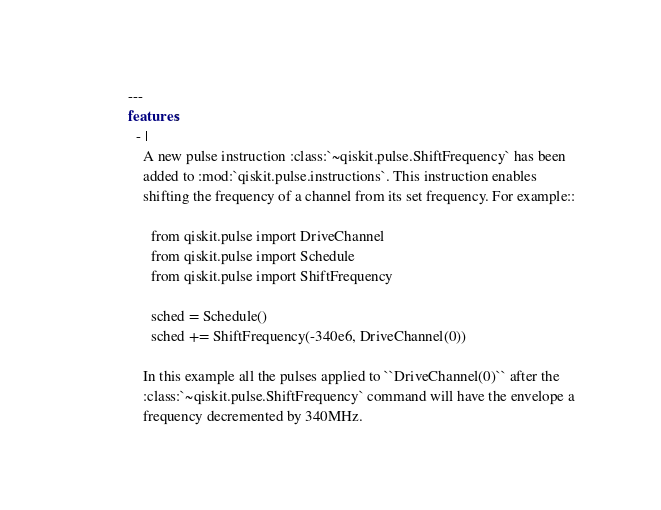Convert code to text. <code><loc_0><loc_0><loc_500><loc_500><_YAML_>---
features:
  - |
    A new pulse instruction :class:`~qiskit.pulse.ShiftFrequency` has been
    added to :mod:`qiskit.pulse.instructions`. This instruction enables
    shifting the frequency of a channel from its set frequency. For example::

      from qiskit.pulse import DriveChannel
      from qiskit.pulse import Schedule
      from qiskit.pulse import ShiftFrequency

      sched = Schedule()
      sched += ShiftFrequency(-340e6, DriveChannel(0))

    In this example all the pulses applied to ``DriveChannel(0)`` after the
    :class:`~qiskit.pulse.ShiftFrequency` command will have the envelope a
    frequency decremented by 340MHz.
</code> 